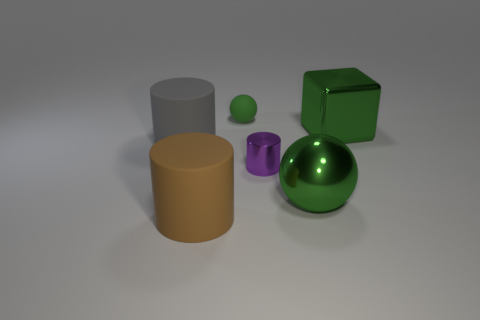What material is the big green thing that is the same shape as the tiny green matte thing?
Ensure brevity in your answer.  Metal. How many other cubes are the same size as the green metallic block?
Keep it short and to the point. 0. What is the size of the gray cylinder that is made of the same material as the tiny green thing?
Offer a terse response. Large. What number of other large metal things have the same shape as the brown object?
Your response must be concise. 0. What number of tiny things are there?
Give a very brief answer. 2. There is a small object on the right side of the tiny sphere; is its shape the same as the big gray matte object?
Provide a short and direct response. Yes. There is a green thing that is the same size as the purple cylinder; what material is it?
Your answer should be compact. Rubber. Is there a big red cylinder that has the same material as the big gray object?
Your response must be concise. No. There is a small purple metal object; is its shape the same as the object that is left of the big brown matte cylinder?
Offer a terse response. Yes. What number of big things are both in front of the green block and on the right side of the gray rubber cylinder?
Ensure brevity in your answer.  2. 